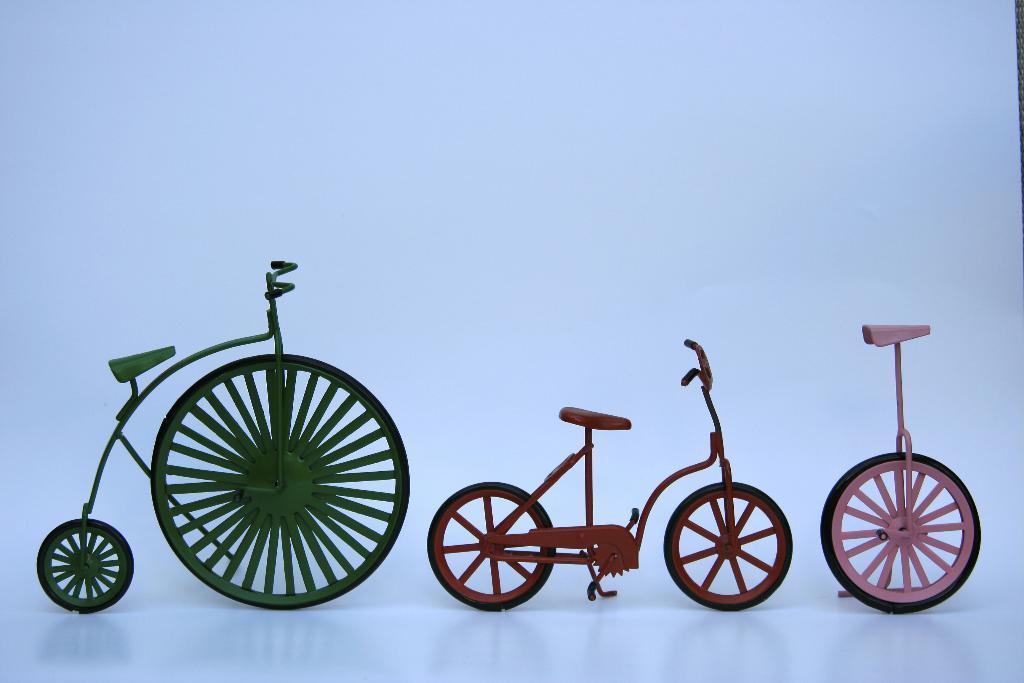Can you describe this image briefly? There are showpieces of two bicycles and one unicycle present on a white color surface as we can see at the bottom of this image. 